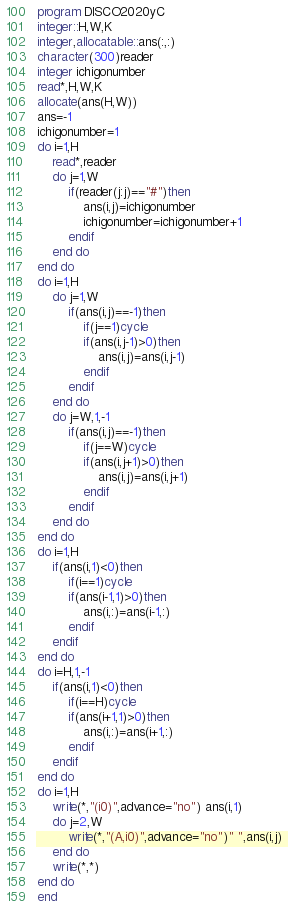Convert code to text. <code><loc_0><loc_0><loc_500><loc_500><_FORTRAN_>program DISCO2020yC
integer::H,W,K
integer,allocatable::ans(:,:)
character(300)reader
integer ichigonumber
read*,H,W,K
allocate(ans(H,W))
ans=-1
ichigonumber=1
do i=1,H
    read*,reader
    do j=1,W
        if(reader(j:j)=="#")then
            ans(i,j)=ichigonumber
            ichigonumber=ichigonumber+1
        endif
    end do
end do
do i=1,H
    do j=1,W
        if(ans(i,j)==-1)then
            if(j==1)cycle
            if(ans(i,j-1)>0)then
                ans(i,j)=ans(i,j-1)
            endif
        endif
    end do
    do j=W,1,-1
        if(ans(i,j)==-1)then
            if(j==W)cycle
            if(ans(i,j+1)>0)then
                ans(i,j)=ans(i,j+1)
            endif
        endif
    end do
end do
do i=1,H
    if(ans(i,1)<0)then
        if(i==1)cycle
        if(ans(i-1,1)>0)then
            ans(i,:)=ans(i-1,:)
        endif
    endif
end do
do i=H,1,-1
    if(ans(i,1)<0)then
        if(i==H)cycle
        if(ans(i+1,1)>0)then
            ans(i,:)=ans(i+1,:)
        endif
    endif
end do
do i=1,H
    write(*,"(i0)",advance="no") ans(i,1)
    do j=2,W
        write(*,"(A,i0)",advance="no")" ",ans(i,j)
    end do
    write(*,*)
end do
end</code> 